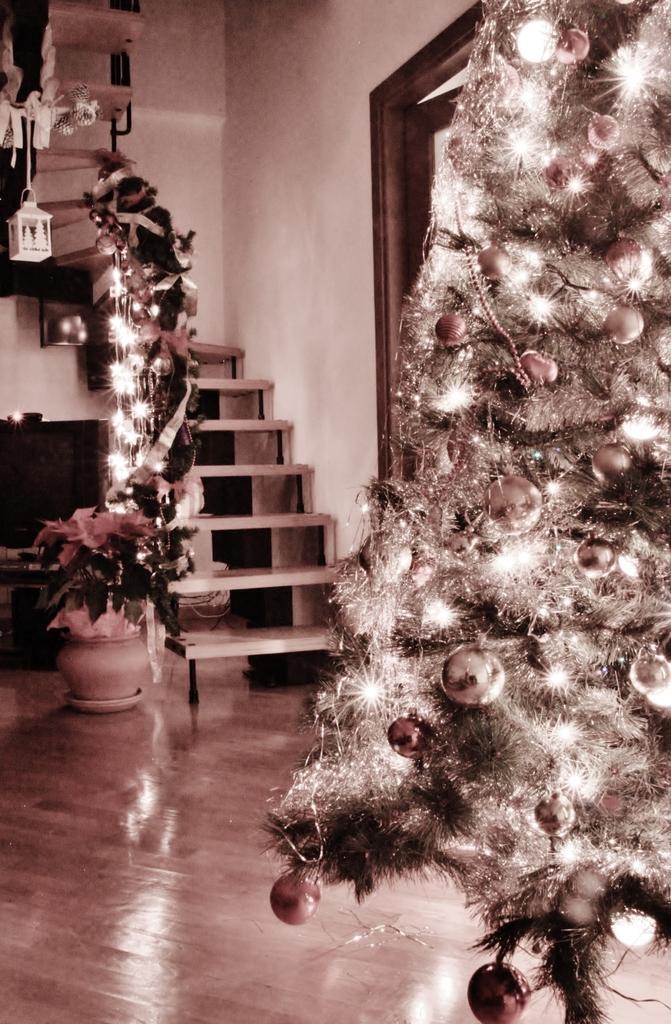Please provide a concise description of this image. There is a Christmas tree presenting in this picture. There is a flower pot on the left side of the image. There are stairs in the middle of the image. 